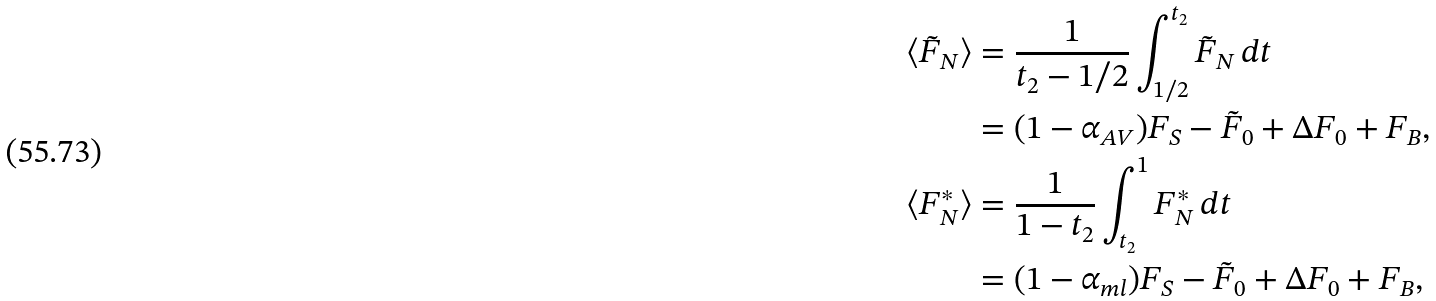Convert formula to latex. <formula><loc_0><loc_0><loc_500><loc_500>\langle \tilde { F } _ { N } \rangle & = \frac { 1 } { t _ { 2 } - 1 / 2 } \int _ { 1 / 2 } ^ { t _ { 2 } } \tilde { F } _ { N } \, d t \\ & = ( 1 - \alpha _ { A V } ) F _ { S } - \tilde { F } _ { 0 } + \Delta F _ { 0 } + F _ { B } , \\ \langle F ^ { * } _ { N } \rangle & = \frac { 1 } { { 1 } - { t _ { 2 } } } \int _ { t _ { 2 } } ^ { 1 } F ^ { * } _ { N } \, d t \\ & = ( 1 - \alpha _ { m l } ) F _ { S } - \tilde { F } _ { 0 } + \Delta F _ { 0 } + F _ { B } ,</formula> 